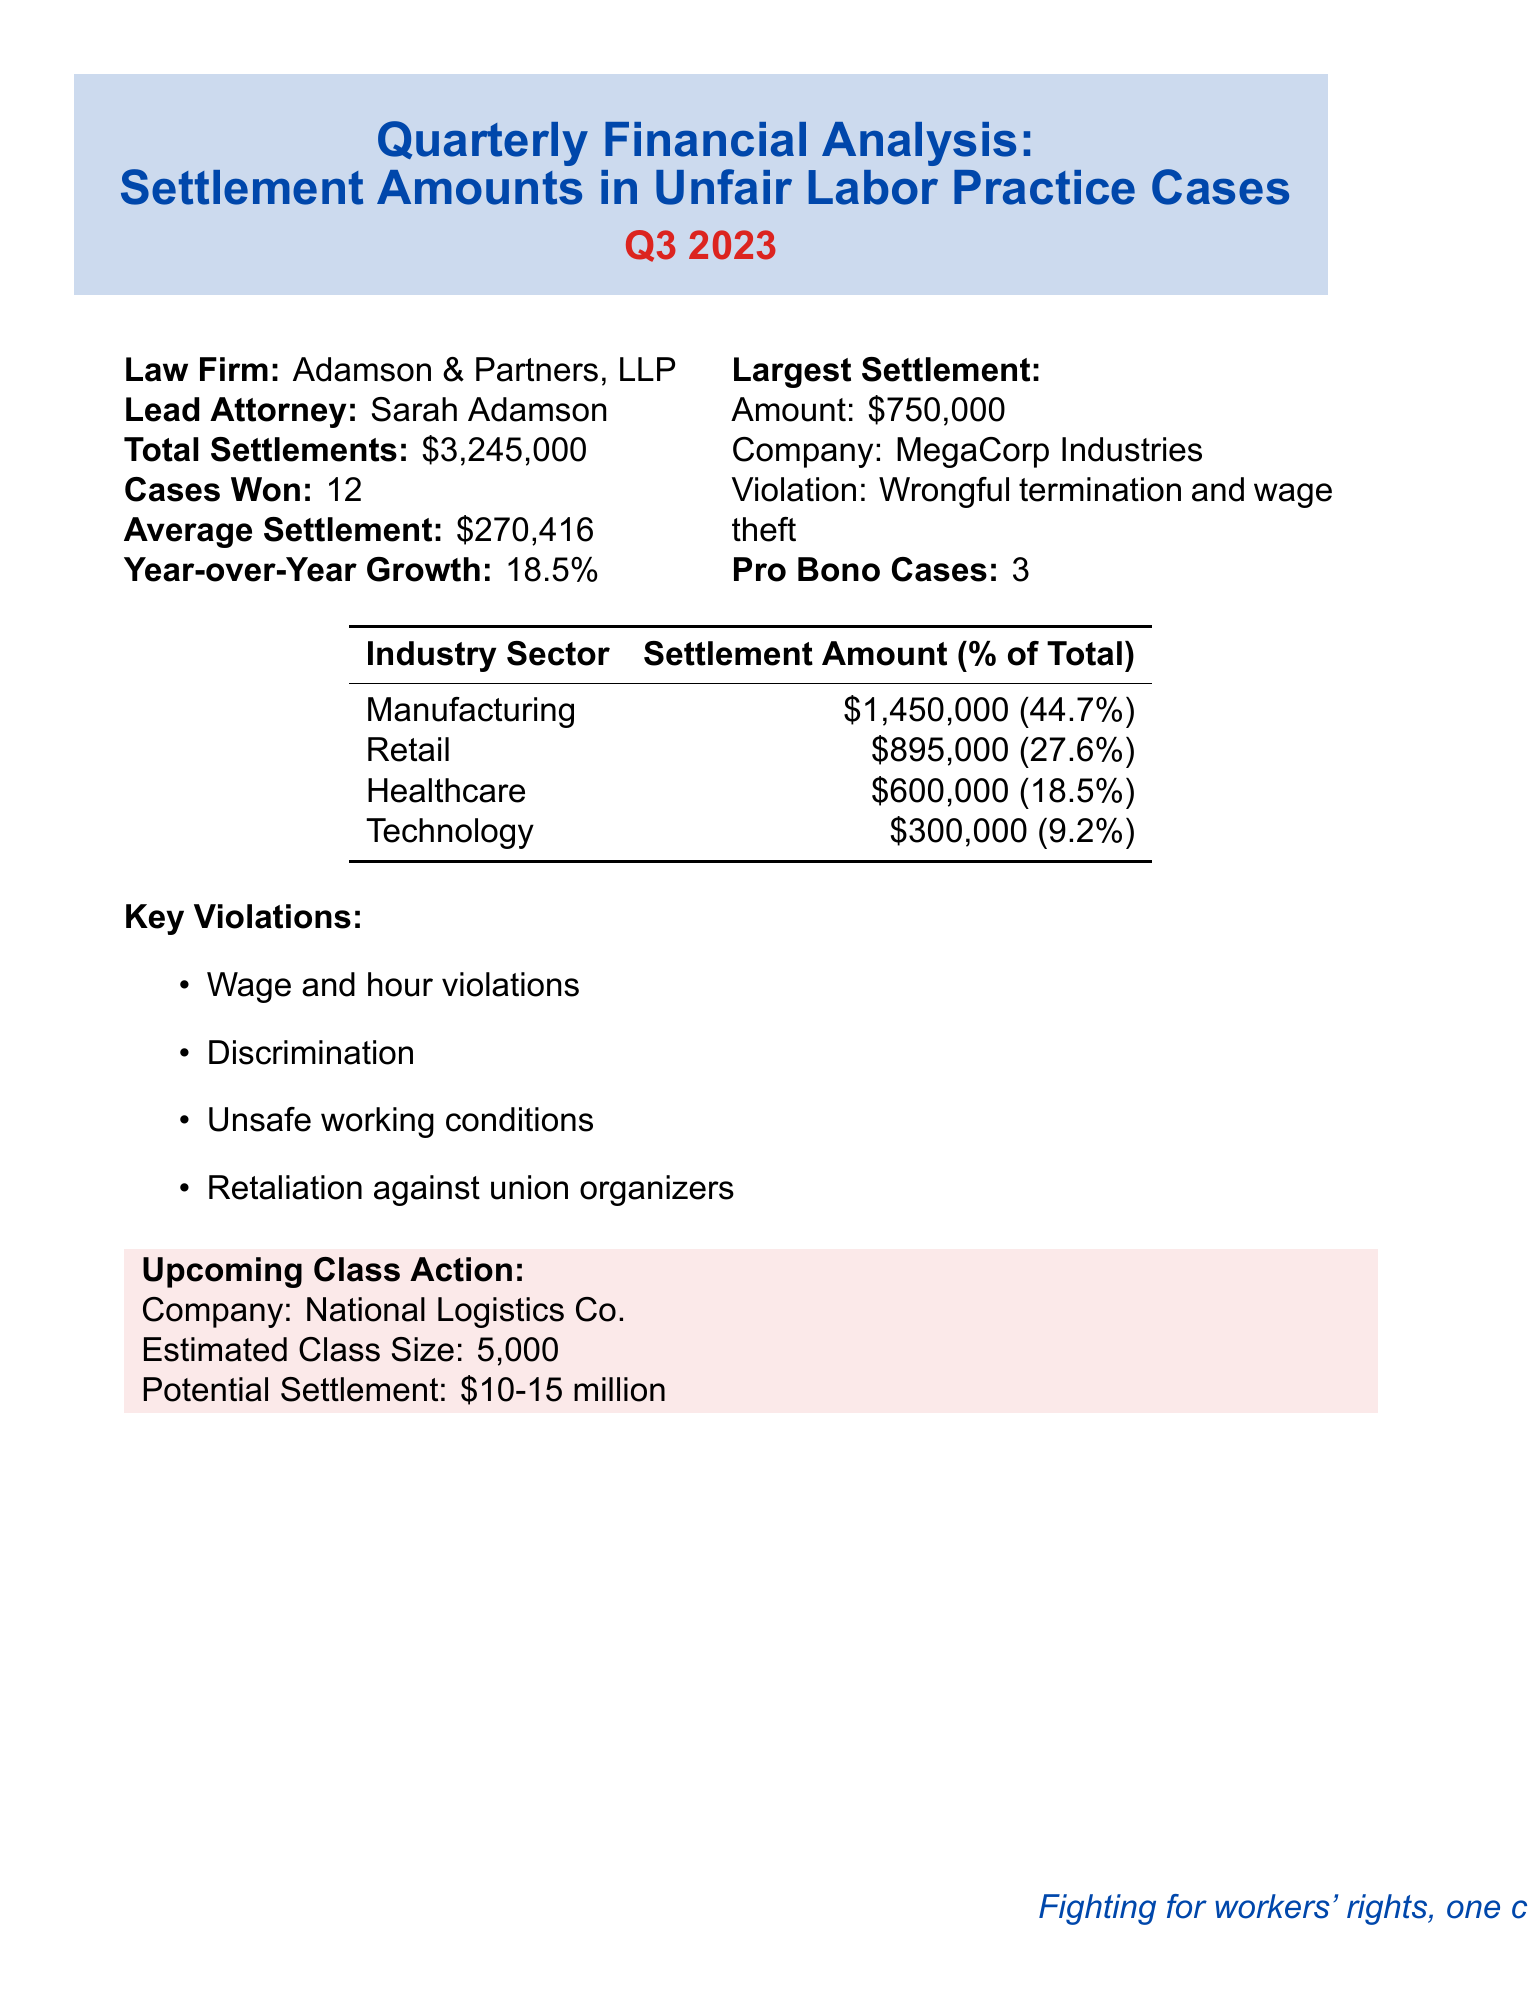what is the total settlements amount? The total settlements amount is explicitly listed in the document under total settlements, which is $3,245,000.
Answer: $3,245,000 who is the lead attorney? The lead attorney is mentioned in the document under lead attorney, which is Sarah Adamson.
Answer: Sarah Adamson how many cases were won? The number of cases won is stated under cases won, which is 12.
Answer: 12 what is the largest settlement amount? The largest settlement amount is detailed under largest settlement, which is $750,000.
Answer: $750,000 what percentage of total settlements came from the Manufacturing sector? The percentage of total settlements from the Manufacturing sector is specified in the industry breakdown, which is 44.7%.
Answer: 44.7% what key violation is related to the largest settlement? The key violation for the largest settlement is listed as wrongful termination and wage theft.
Answer: Wrongful termination and wage theft how many pro bono cases were handled? The document mentions the number of pro bono cases under pro bono cases, which is 3.
Answer: 3 what is the estimated size of the upcoming class action? The estimated size of the upcoming class action is noted in the upcoming class action section, which is 5,000.
Answer: 5,000 what is the year-over-year growth percentage? The year-over-year growth percentage is found under year-over-year growth, which is 18.5%.
Answer: 18.5% which company is involved in the upcoming class action? The company involved in the upcoming class action is mentioned in the upcoming class action section, which is National Logistics Co.
Answer: National Logistics Co 